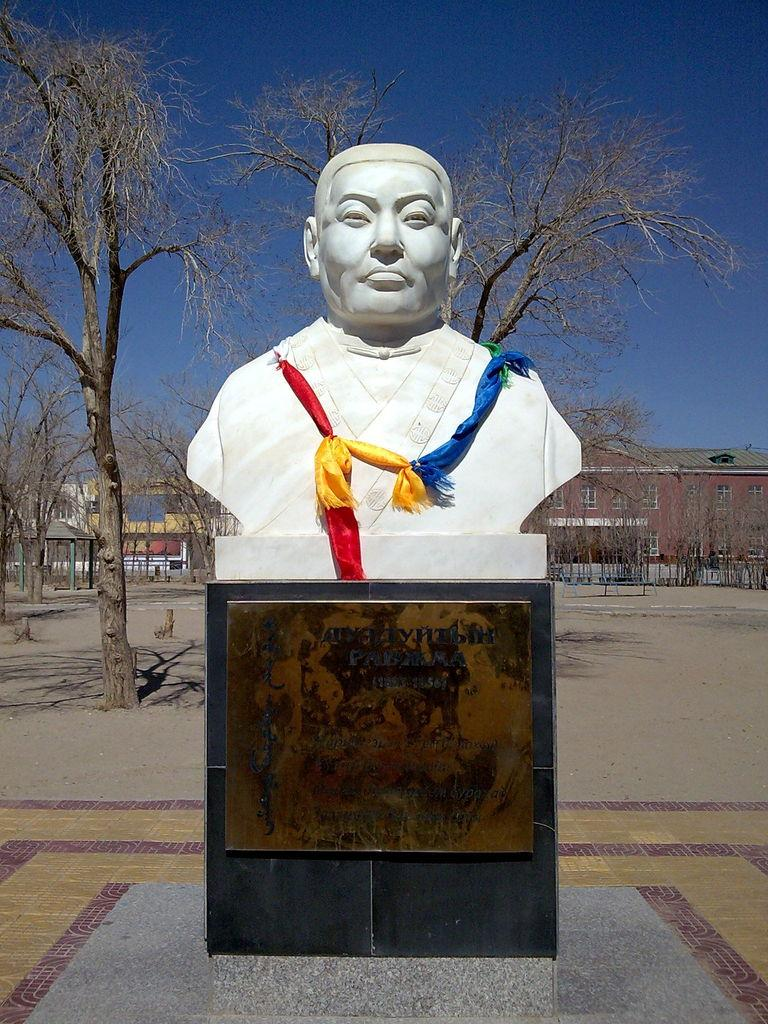What is the main subject in the foreground of the image? There is a sculpture in the foreground of the image. What can be seen in the background of the image? There are buildings, trees, land, and the sky visible in the background of the image. What type of loaf is the sculpture holding in the image? The sculpture is not holding a loaf in the image; it is a stationary object. Is the sculpture reading a book in the image? There is no book or any indication of reading in the image; the sculpture is the main subject. 